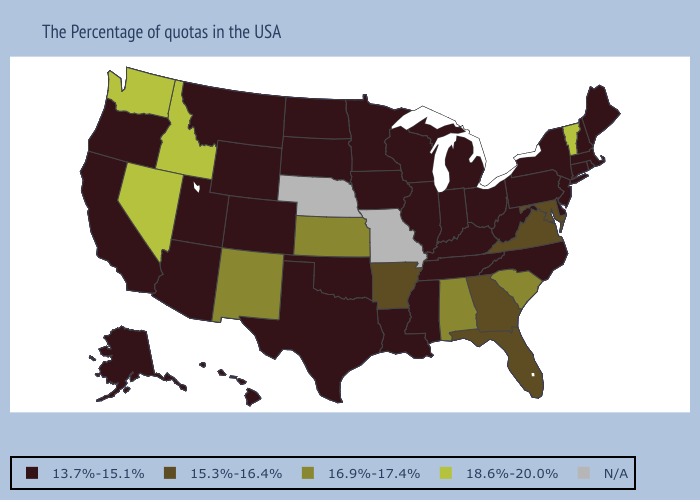What is the value of Idaho?
Quick response, please. 18.6%-20.0%. Among the states that border Texas , which have the highest value?
Concise answer only. New Mexico. Does the map have missing data?
Be succinct. Yes. Among the states that border Idaho , does Oregon have the lowest value?
Keep it brief. Yes. Name the states that have a value in the range 18.6%-20.0%?
Keep it brief. Vermont, Idaho, Nevada, Washington. Which states have the lowest value in the USA?
Answer briefly. Maine, Massachusetts, Rhode Island, New Hampshire, Connecticut, New York, New Jersey, Delaware, Pennsylvania, North Carolina, West Virginia, Ohio, Michigan, Kentucky, Indiana, Tennessee, Wisconsin, Illinois, Mississippi, Louisiana, Minnesota, Iowa, Oklahoma, Texas, South Dakota, North Dakota, Wyoming, Colorado, Utah, Montana, Arizona, California, Oregon, Alaska, Hawaii. What is the value of Nevada?
Write a very short answer. 18.6%-20.0%. Is the legend a continuous bar?
Keep it brief. No. What is the value of Pennsylvania?
Write a very short answer. 13.7%-15.1%. Among the states that border Arizona , which have the highest value?
Write a very short answer. Nevada. What is the value of Virginia?
Quick response, please. 15.3%-16.4%. What is the value of South Carolina?
Answer briefly. 16.9%-17.4%. Does the first symbol in the legend represent the smallest category?
Be succinct. Yes. Among the states that border Massachusetts , does Connecticut have the highest value?
Keep it brief. No. 